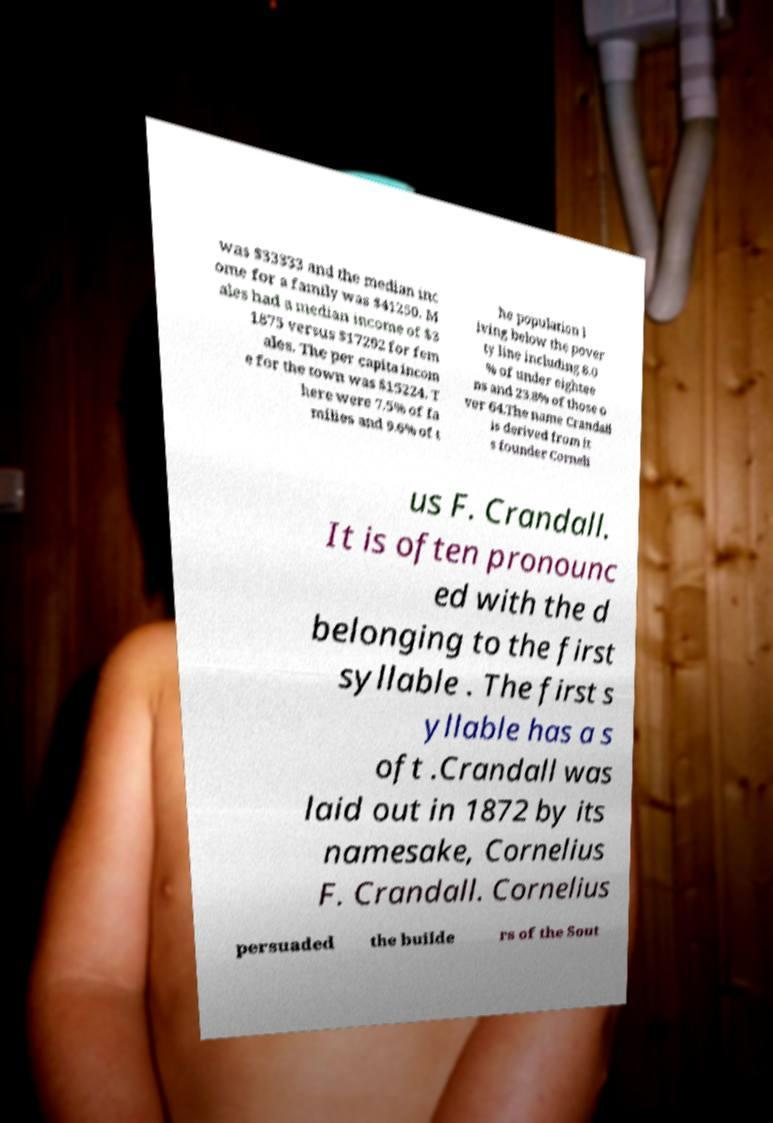Can you read and provide the text displayed in the image?This photo seems to have some interesting text. Can you extract and type it out for me? was $33333 and the median inc ome for a family was $41250. M ales had a median income of $3 1875 versus $17292 for fem ales. The per capita incom e for the town was $15224. T here were 7.5% of fa milies and 9.6% of t he population l iving below the pover ty line including 8.0 % of under eightee ns and 23.8% of those o ver 64.The name Crandall is derived from it s founder Corneli us F. Crandall. It is often pronounc ed with the d belonging to the first syllable . The first s yllable has a s oft .Crandall was laid out in 1872 by its namesake, Cornelius F. Crandall. Cornelius persuaded the builde rs of the Sout 